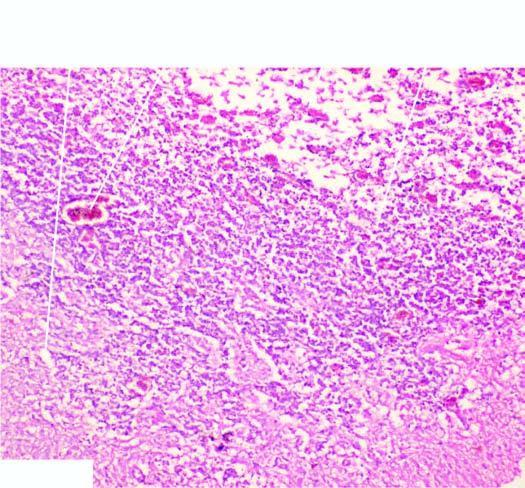what are reactive astrocytosis, a few reactive macrophages and neovascularisation in the wall of the cystic lesion?
Answer the question using a single word or phrase. Histologic changes 